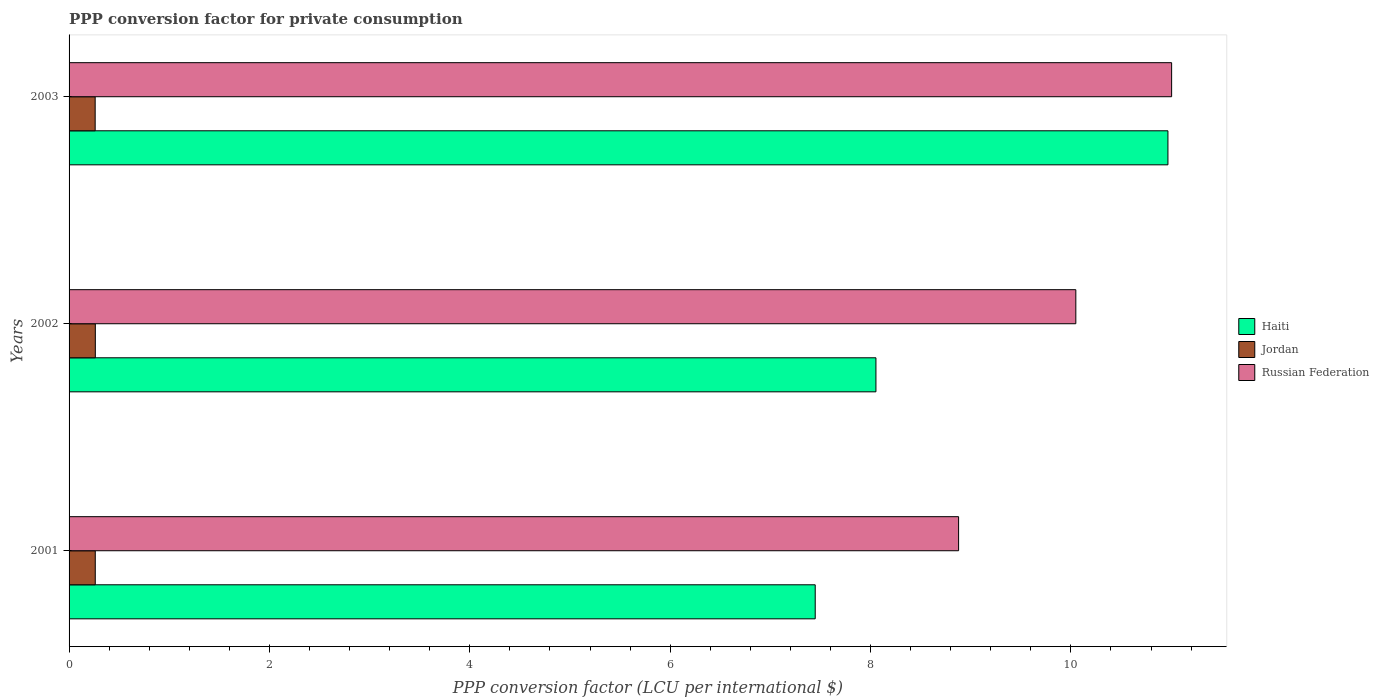How many groups of bars are there?
Make the answer very short. 3. Are the number of bars per tick equal to the number of legend labels?
Offer a very short reply. Yes. Are the number of bars on each tick of the Y-axis equal?
Your answer should be compact. Yes. In how many cases, is the number of bars for a given year not equal to the number of legend labels?
Provide a short and direct response. 0. What is the PPP conversion factor for private consumption in Russian Federation in 2001?
Your response must be concise. 8.88. Across all years, what is the maximum PPP conversion factor for private consumption in Jordan?
Your response must be concise. 0.26. Across all years, what is the minimum PPP conversion factor for private consumption in Haiti?
Give a very brief answer. 7.45. In which year was the PPP conversion factor for private consumption in Haiti maximum?
Provide a short and direct response. 2003. What is the total PPP conversion factor for private consumption in Haiti in the graph?
Provide a short and direct response. 26.47. What is the difference between the PPP conversion factor for private consumption in Haiti in 2001 and that in 2003?
Provide a short and direct response. -3.52. What is the difference between the PPP conversion factor for private consumption in Jordan in 2003 and the PPP conversion factor for private consumption in Haiti in 2002?
Provide a short and direct response. -7.79. What is the average PPP conversion factor for private consumption in Jordan per year?
Your answer should be very brief. 0.26. In the year 2003, what is the difference between the PPP conversion factor for private consumption in Russian Federation and PPP conversion factor for private consumption in Jordan?
Give a very brief answer. 10.74. In how many years, is the PPP conversion factor for private consumption in Russian Federation greater than 7.6 LCU?
Your answer should be compact. 3. What is the ratio of the PPP conversion factor for private consumption in Russian Federation in 2001 to that in 2002?
Keep it short and to the point. 0.88. Is the PPP conversion factor for private consumption in Jordan in 2001 less than that in 2003?
Your response must be concise. No. What is the difference between the highest and the second highest PPP conversion factor for private consumption in Russian Federation?
Provide a succinct answer. 0.96. What is the difference between the highest and the lowest PPP conversion factor for private consumption in Haiti?
Ensure brevity in your answer.  3.52. In how many years, is the PPP conversion factor for private consumption in Jordan greater than the average PPP conversion factor for private consumption in Jordan taken over all years?
Keep it short and to the point. 2. What does the 2nd bar from the top in 2003 represents?
Ensure brevity in your answer.  Jordan. What does the 1st bar from the bottom in 2003 represents?
Give a very brief answer. Haiti. Is it the case that in every year, the sum of the PPP conversion factor for private consumption in Jordan and PPP conversion factor for private consumption in Russian Federation is greater than the PPP conversion factor for private consumption in Haiti?
Ensure brevity in your answer.  Yes. Are the values on the major ticks of X-axis written in scientific E-notation?
Offer a terse response. No. Does the graph contain any zero values?
Provide a short and direct response. No. Where does the legend appear in the graph?
Keep it short and to the point. Center right. How many legend labels are there?
Ensure brevity in your answer.  3. What is the title of the graph?
Your response must be concise. PPP conversion factor for private consumption. What is the label or title of the X-axis?
Your answer should be very brief. PPP conversion factor (LCU per international $). What is the label or title of the Y-axis?
Give a very brief answer. Years. What is the PPP conversion factor (LCU per international $) in Haiti in 2001?
Your answer should be very brief. 7.45. What is the PPP conversion factor (LCU per international $) in Jordan in 2001?
Make the answer very short. 0.26. What is the PPP conversion factor (LCU per international $) in Russian Federation in 2001?
Make the answer very short. 8.88. What is the PPP conversion factor (LCU per international $) of Haiti in 2002?
Ensure brevity in your answer.  8.05. What is the PPP conversion factor (LCU per international $) in Jordan in 2002?
Make the answer very short. 0.26. What is the PPP conversion factor (LCU per international $) in Russian Federation in 2002?
Your answer should be compact. 10.05. What is the PPP conversion factor (LCU per international $) in Haiti in 2003?
Offer a terse response. 10.97. What is the PPP conversion factor (LCU per international $) of Jordan in 2003?
Offer a terse response. 0.26. What is the PPP conversion factor (LCU per international $) in Russian Federation in 2003?
Ensure brevity in your answer.  11.01. Across all years, what is the maximum PPP conversion factor (LCU per international $) of Haiti?
Make the answer very short. 10.97. Across all years, what is the maximum PPP conversion factor (LCU per international $) in Jordan?
Ensure brevity in your answer.  0.26. Across all years, what is the maximum PPP conversion factor (LCU per international $) of Russian Federation?
Provide a short and direct response. 11.01. Across all years, what is the minimum PPP conversion factor (LCU per international $) of Haiti?
Your response must be concise. 7.45. Across all years, what is the minimum PPP conversion factor (LCU per international $) in Jordan?
Offer a terse response. 0.26. Across all years, what is the minimum PPP conversion factor (LCU per international $) of Russian Federation?
Give a very brief answer. 8.88. What is the total PPP conversion factor (LCU per international $) in Haiti in the graph?
Make the answer very short. 26.47. What is the total PPP conversion factor (LCU per international $) in Jordan in the graph?
Ensure brevity in your answer.  0.78. What is the total PPP conversion factor (LCU per international $) in Russian Federation in the graph?
Provide a short and direct response. 29.93. What is the difference between the PPP conversion factor (LCU per international $) in Haiti in 2001 and that in 2002?
Ensure brevity in your answer.  -0.61. What is the difference between the PPP conversion factor (LCU per international $) in Jordan in 2001 and that in 2002?
Make the answer very short. -0. What is the difference between the PPP conversion factor (LCU per international $) of Russian Federation in 2001 and that in 2002?
Give a very brief answer. -1.17. What is the difference between the PPP conversion factor (LCU per international $) in Haiti in 2001 and that in 2003?
Offer a terse response. -3.52. What is the difference between the PPP conversion factor (LCU per international $) of Jordan in 2001 and that in 2003?
Make the answer very short. 0. What is the difference between the PPP conversion factor (LCU per international $) of Russian Federation in 2001 and that in 2003?
Make the answer very short. -2.13. What is the difference between the PPP conversion factor (LCU per international $) in Haiti in 2002 and that in 2003?
Offer a very short reply. -2.91. What is the difference between the PPP conversion factor (LCU per international $) of Jordan in 2002 and that in 2003?
Provide a short and direct response. 0. What is the difference between the PPP conversion factor (LCU per international $) of Russian Federation in 2002 and that in 2003?
Keep it short and to the point. -0.96. What is the difference between the PPP conversion factor (LCU per international $) in Haiti in 2001 and the PPP conversion factor (LCU per international $) in Jordan in 2002?
Provide a succinct answer. 7.19. What is the difference between the PPP conversion factor (LCU per international $) of Haiti in 2001 and the PPP conversion factor (LCU per international $) of Russian Federation in 2002?
Make the answer very short. -2.6. What is the difference between the PPP conversion factor (LCU per international $) in Jordan in 2001 and the PPP conversion factor (LCU per international $) in Russian Federation in 2002?
Offer a very short reply. -9.79. What is the difference between the PPP conversion factor (LCU per international $) of Haiti in 2001 and the PPP conversion factor (LCU per international $) of Jordan in 2003?
Offer a terse response. 7.19. What is the difference between the PPP conversion factor (LCU per international $) of Haiti in 2001 and the PPP conversion factor (LCU per international $) of Russian Federation in 2003?
Keep it short and to the point. -3.56. What is the difference between the PPP conversion factor (LCU per international $) of Jordan in 2001 and the PPP conversion factor (LCU per international $) of Russian Federation in 2003?
Provide a succinct answer. -10.74. What is the difference between the PPP conversion factor (LCU per international $) in Haiti in 2002 and the PPP conversion factor (LCU per international $) in Jordan in 2003?
Provide a short and direct response. 7.79. What is the difference between the PPP conversion factor (LCU per international $) in Haiti in 2002 and the PPP conversion factor (LCU per international $) in Russian Federation in 2003?
Provide a short and direct response. -2.95. What is the difference between the PPP conversion factor (LCU per international $) of Jordan in 2002 and the PPP conversion factor (LCU per international $) of Russian Federation in 2003?
Your response must be concise. -10.74. What is the average PPP conversion factor (LCU per international $) of Haiti per year?
Provide a short and direct response. 8.82. What is the average PPP conversion factor (LCU per international $) in Jordan per year?
Provide a short and direct response. 0.26. What is the average PPP conversion factor (LCU per international $) of Russian Federation per year?
Offer a terse response. 9.98. In the year 2001, what is the difference between the PPP conversion factor (LCU per international $) of Haiti and PPP conversion factor (LCU per international $) of Jordan?
Give a very brief answer. 7.19. In the year 2001, what is the difference between the PPP conversion factor (LCU per international $) of Haiti and PPP conversion factor (LCU per international $) of Russian Federation?
Ensure brevity in your answer.  -1.43. In the year 2001, what is the difference between the PPP conversion factor (LCU per international $) of Jordan and PPP conversion factor (LCU per international $) of Russian Federation?
Offer a very short reply. -8.62. In the year 2002, what is the difference between the PPP conversion factor (LCU per international $) of Haiti and PPP conversion factor (LCU per international $) of Jordan?
Offer a terse response. 7.79. In the year 2002, what is the difference between the PPP conversion factor (LCU per international $) of Haiti and PPP conversion factor (LCU per international $) of Russian Federation?
Give a very brief answer. -2. In the year 2002, what is the difference between the PPP conversion factor (LCU per international $) of Jordan and PPP conversion factor (LCU per international $) of Russian Federation?
Ensure brevity in your answer.  -9.79. In the year 2003, what is the difference between the PPP conversion factor (LCU per international $) in Haiti and PPP conversion factor (LCU per international $) in Jordan?
Your answer should be compact. 10.71. In the year 2003, what is the difference between the PPP conversion factor (LCU per international $) of Haiti and PPP conversion factor (LCU per international $) of Russian Federation?
Ensure brevity in your answer.  -0.04. In the year 2003, what is the difference between the PPP conversion factor (LCU per international $) of Jordan and PPP conversion factor (LCU per international $) of Russian Federation?
Provide a succinct answer. -10.74. What is the ratio of the PPP conversion factor (LCU per international $) in Haiti in 2001 to that in 2002?
Your answer should be very brief. 0.92. What is the ratio of the PPP conversion factor (LCU per international $) in Jordan in 2001 to that in 2002?
Keep it short and to the point. 1. What is the ratio of the PPP conversion factor (LCU per international $) of Russian Federation in 2001 to that in 2002?
Keep it short and to the point. 0.88. What is the ratio of the PPP conversion factor (LCU per international $) in Haiti in 2001 to that in 2003?
Provide a short and direct response. 0.68. What is the ratio of the PPP conversion factor (LCU per international $) in Jordan in 2001 to that in 2003?
Offer a terse response. 1. What is the ratio of the PPP conversion factor (LCU per international $) in Russian Federation in 2001 to that in 2003?
Ensure brevity in your answer.  0.81. What is the ratio of the PPP conversion factor (LCU per international $) in Haiti in 2002 to that in 2003?
Provide a succinct answer. 0.73. What is the ratio of the PPP conversion factor (LCU per international $) in Jordan in 2002 to that in 2003?
Provide a succinct answer. 1.01. What is the ratio of the PPP conversion factor (LCU per international $) in Russian Federation in 2002 to that in 2003?
Provide a succinct answer. 0.91. What is the difference between the highest and the second highest PPP conversion factor (LCU per international $) of Haiti?
Give a very brief answer. 2.91. What is the difference between the highest and the second highest PPP conversion factor (LCU per international $) of Jordan?
Your answer should be compact. 0. What is the difference between the highest and the second highest PPP conversion factor (LCU per international $) in Russian Federation?
Your response must be concise. 0.96. What is the difference between the highest and the lowest PPP conversion factor (LCU per international $) in Haiti?
Give a very brief answer. 3.52. What is the difference between the highest and the lowest PPP conversion factor (LCU per international $) of Jordan?
Provide a short and direct response. 0. What is the difference between the highest and the lowest PPP conversion factor (LCU per international $) in Russian Federation?
Provide a succinct answer. 2.13. 